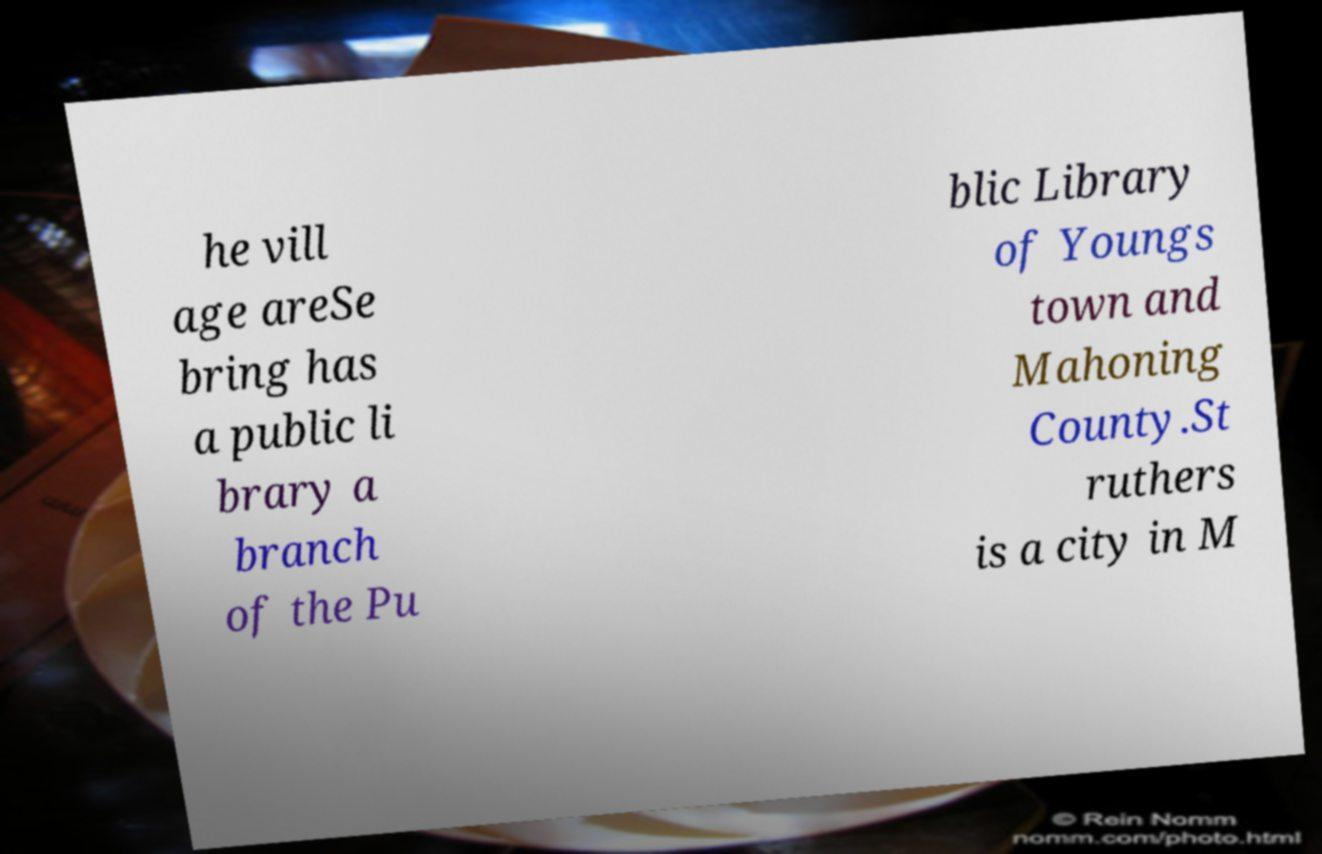Can you accurately transcribe the text from the provided image for me? he vill age areSe bring has a public li brary a branch of the Pu blic Library of Youngs town and Mahoning County.St ruthers is a city in M 